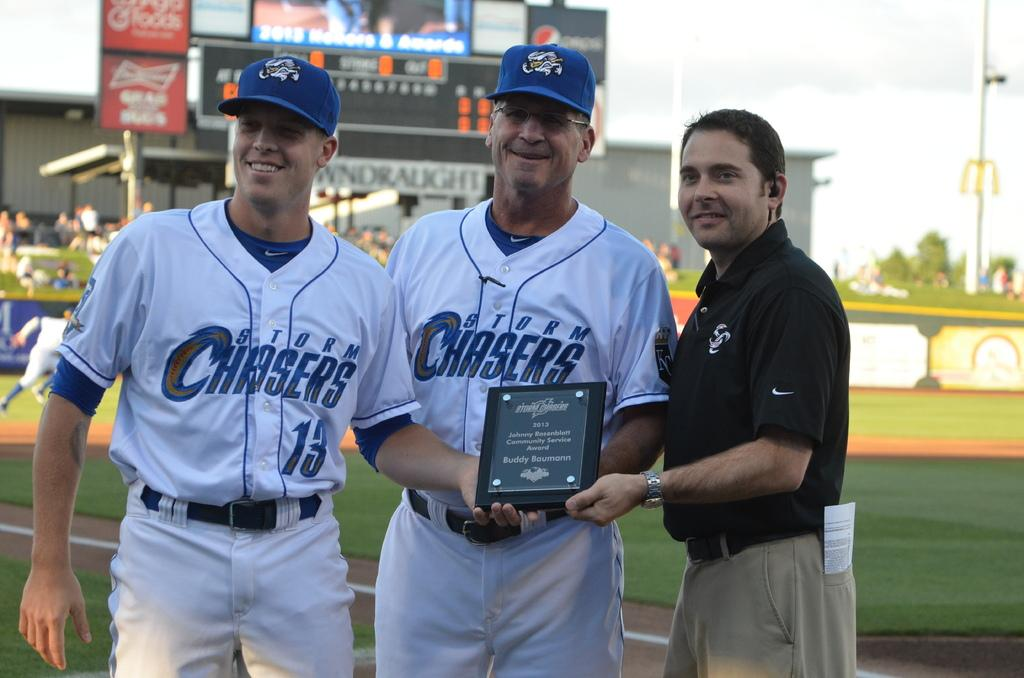<image>
Relay a brief, clear account of the picture shown. Two player from Storm Chasers and a coach holding the trophy 